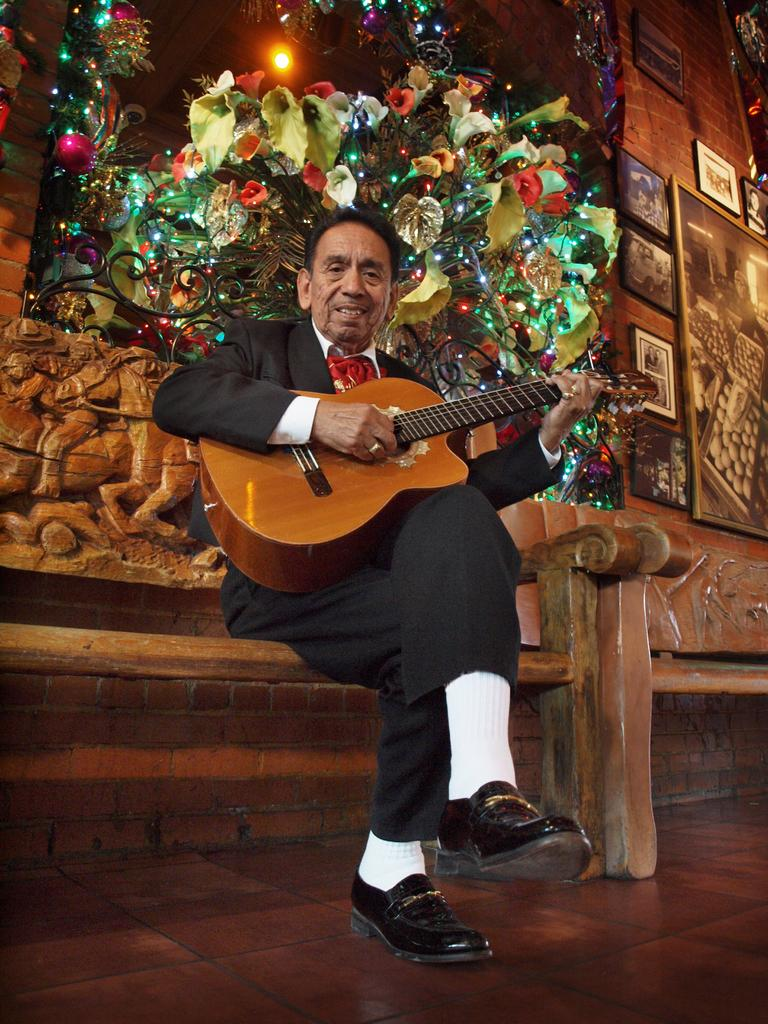What is the man in the image doing? The man is playing a guitar in the image. What else can be seen in the image besides the man and his guitar? There are plants and photo frames in the image. Can you describe the plants in the image? Unfortunately, the facts provided do not give enough detail to describe the plants in the image. What is the purpose of the photo frames in the image? The purpose of the photo frames in the image is not clear from the provided facts. What type of quartz can be seen in the image? There is no quartz present in the image. What authority figure is depicted in the image? There is no authority figure depicted in the image. 